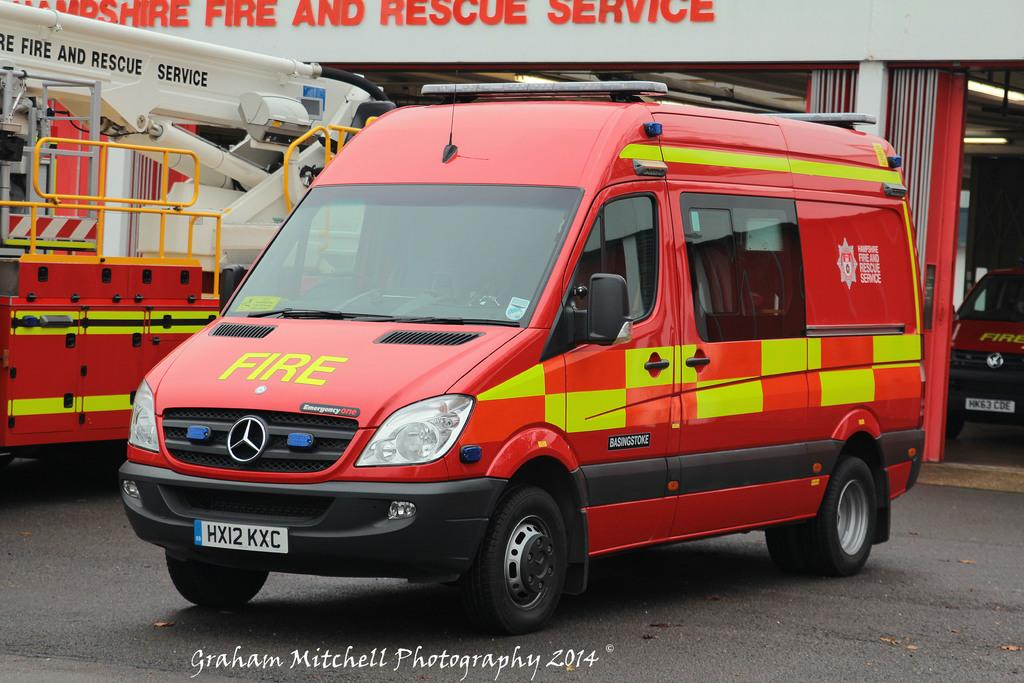<image>
Provide a brief description of the given image. HX12 KXC reads the license plate of this fire service van. 